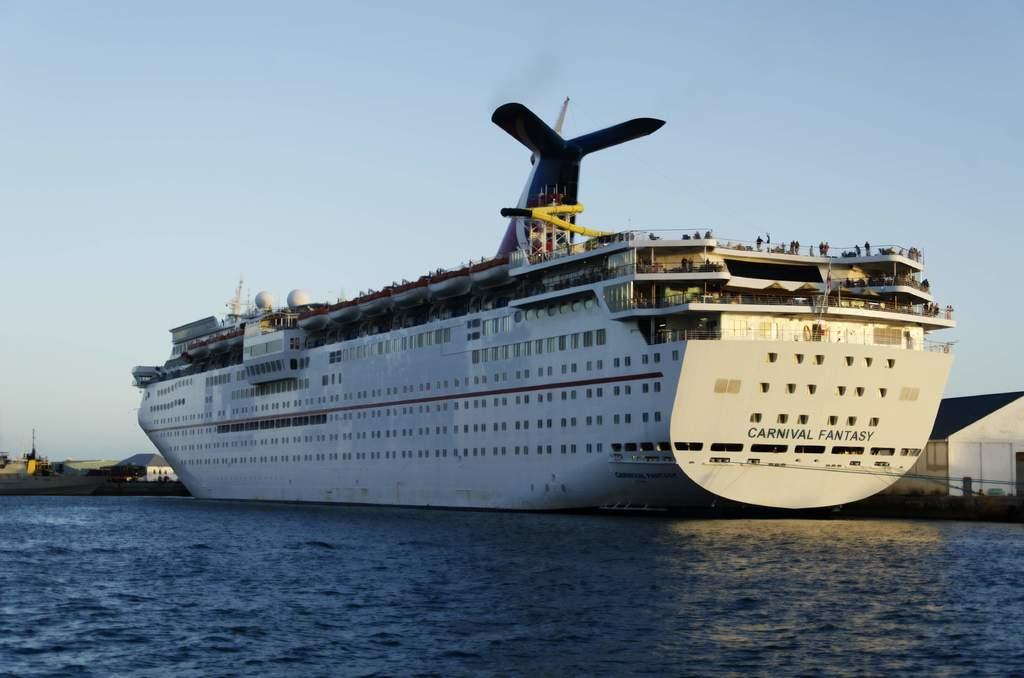What is the name of the cruise liner?
Keep it short and to the point. Carnival fantasy. 